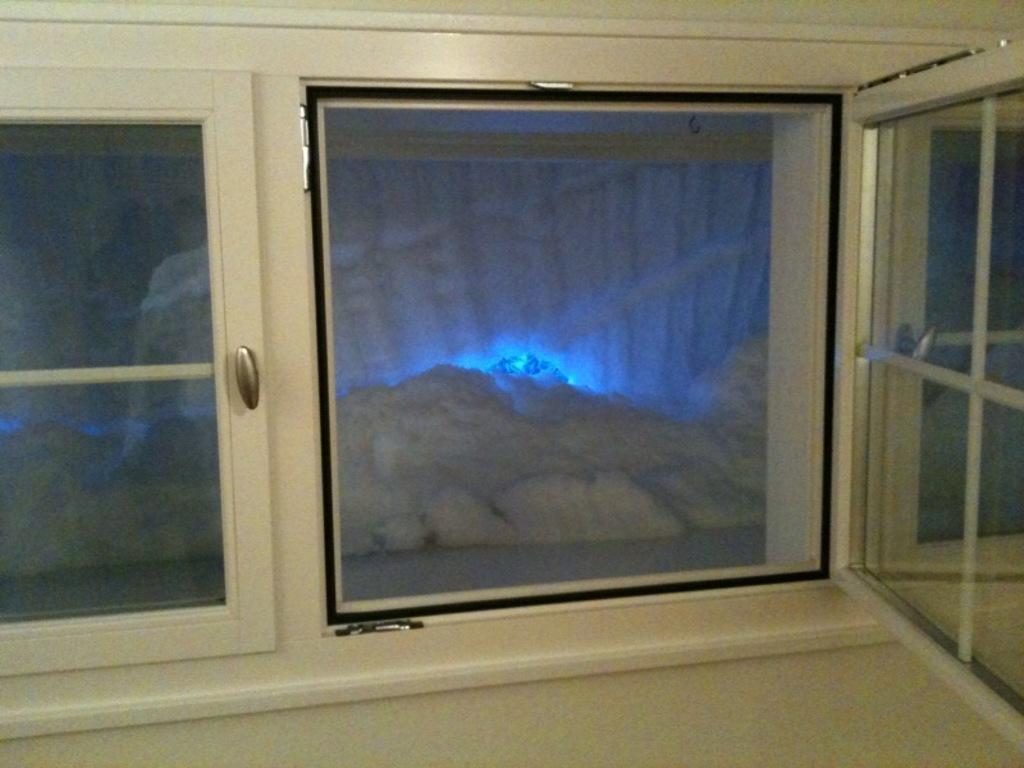Please provide a concise description of this image. In this picture we can see the floor, beside this floor we can see a window and doors. 